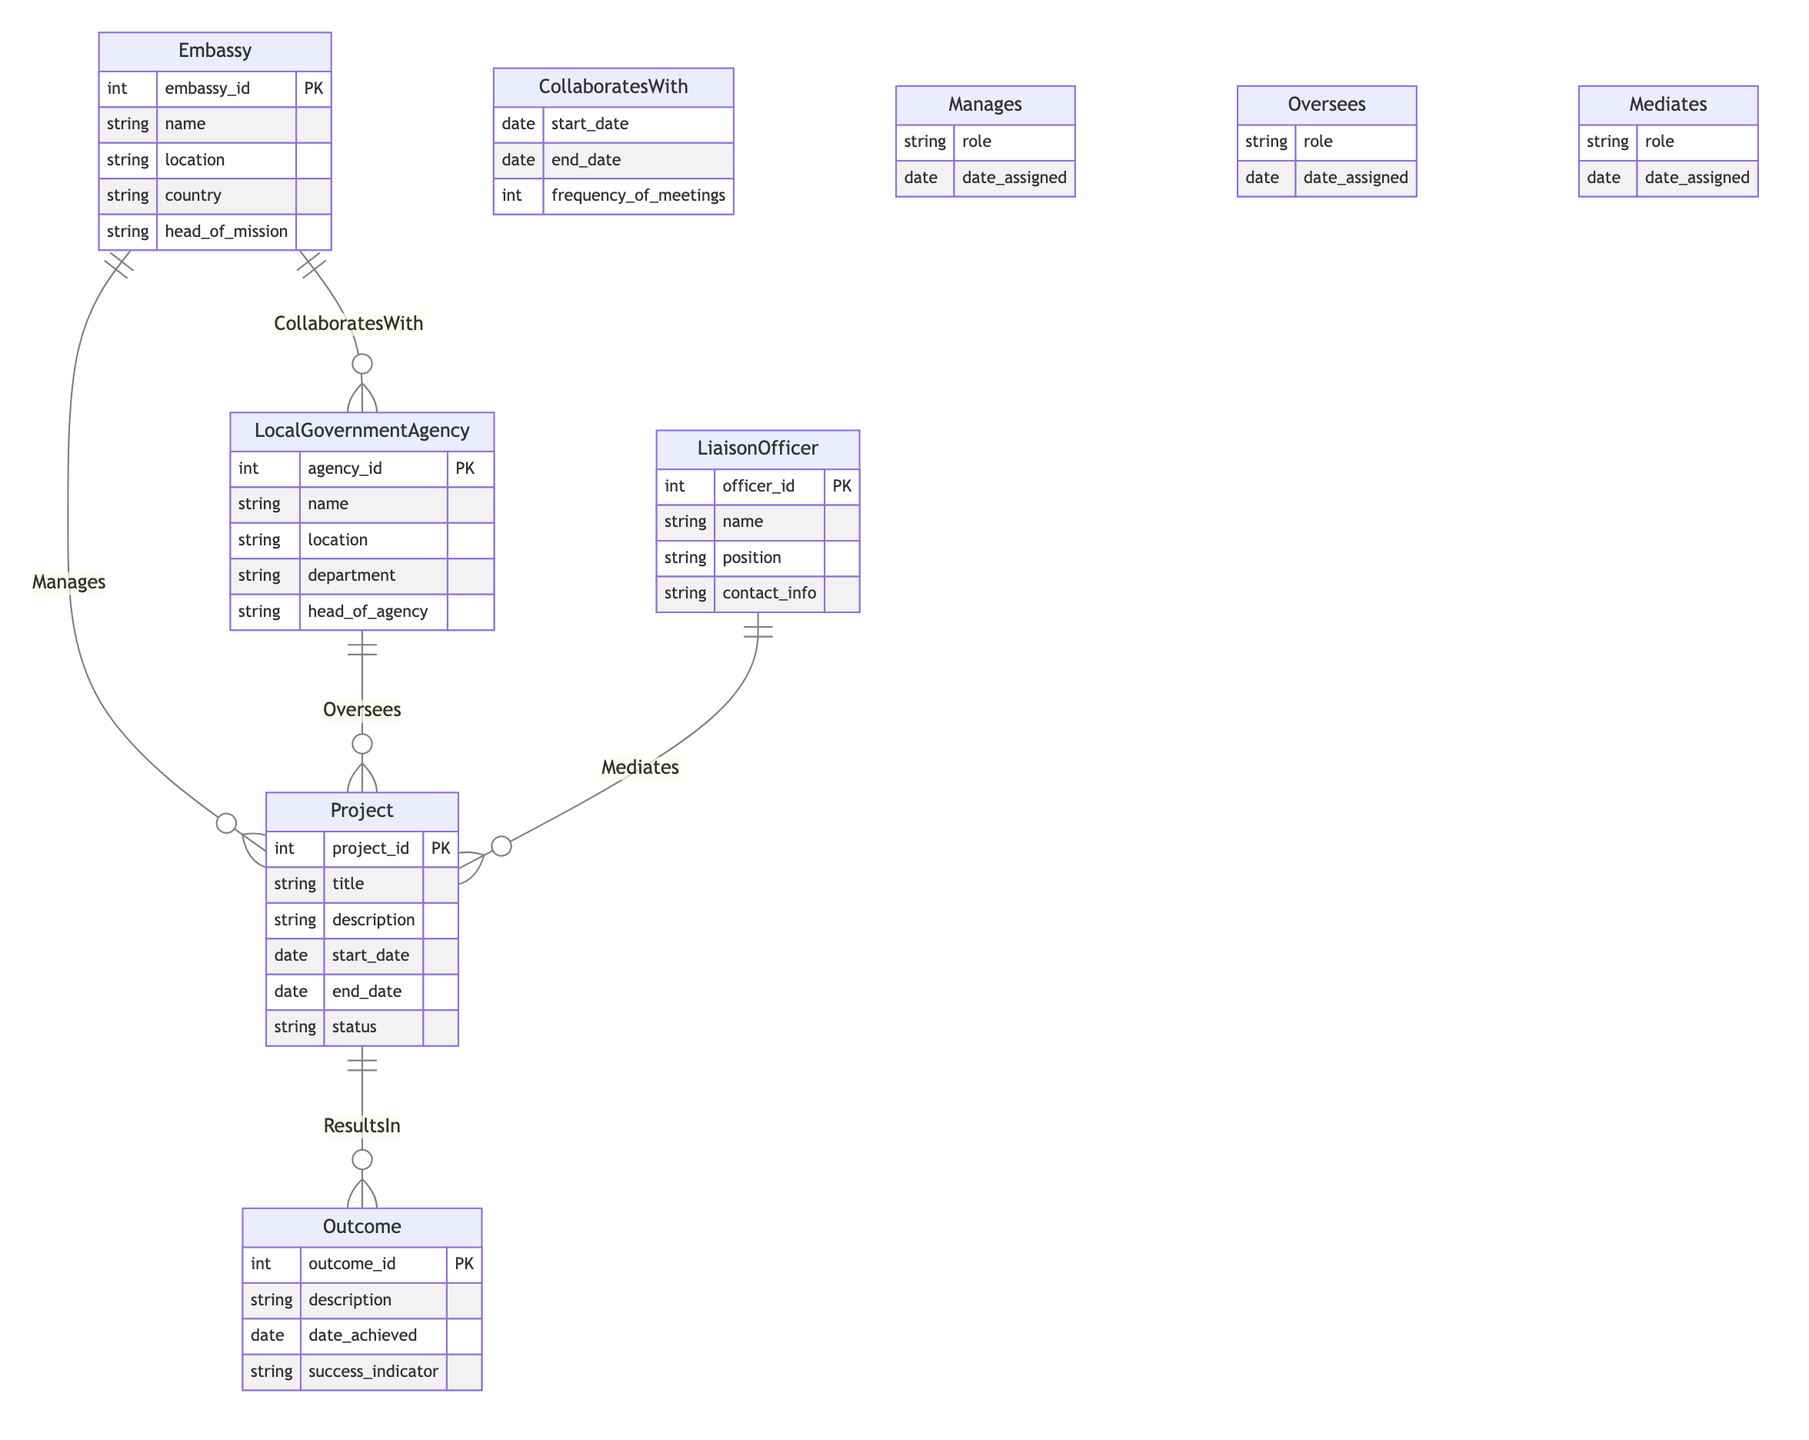What entities are involved in the collaboration? The diagram shows two entities involved in the collaboration: Embassy and Local Government Agency, connected through the "CollaboratesWith" relationship.
Answer: Embassy, Local Government Agency What is the primary attribute of the Project entity? The Project entity has several attributes, but the primary identifier is "project_id," which uniquely distinguishes each project in the diagram.
Answer: project_id How many relationships are there between Project and Outcome? The diagram indicates a single relationship called "ResultsIn," connecting each Project to its respective Outcome.
Answer: 1 What does the Liaison Officer do in relation to projects? The Liaison Officer mediates the projects, as indicated by the "Mediates" relationship connecting Liaison Officer to Project entities.
Answer: Mediates Which entity oversees the projects? The Local Government Agency oversees the projects, as reflected in the relationship named "Oversees" that connects Local Government Agency to Project.
Answer: Local Government Agency What additional information is included in the Collaborates With relationship? The Collaborates With relationship includes attributes such as "start_date," "end_date," and "frequency_of_meetings," which denote the nature of the collaboration.
Answer: start_date, end_date, frequency_of_meetings What role does the Embassy play in managing projects? In the context of the diagram, the Embassy plays the role of managing projects based on the "Manages" relationship, which implies responsibility for certain projects.
Answer: Manages What type of information does the Outcome entity contain? The Outcome entity contains information including "description," "date_achieved," and "success_indicator," which specify the results of the projects.
Answer: description, date_achieved, success_indicator How many attributes does the Local Government Agency entity have? The Local Government Agency entity has five attributes listed in the diagram: agency_id, name, location, department, and head_of_agency.
Answer: 5 What is the relationship between the Project and Outcome entities? The Project and Outcome entities are connected by the "ResultsIn" relationship, indicating that projects lead to specific outcomes.
Answer: ResultsIn 